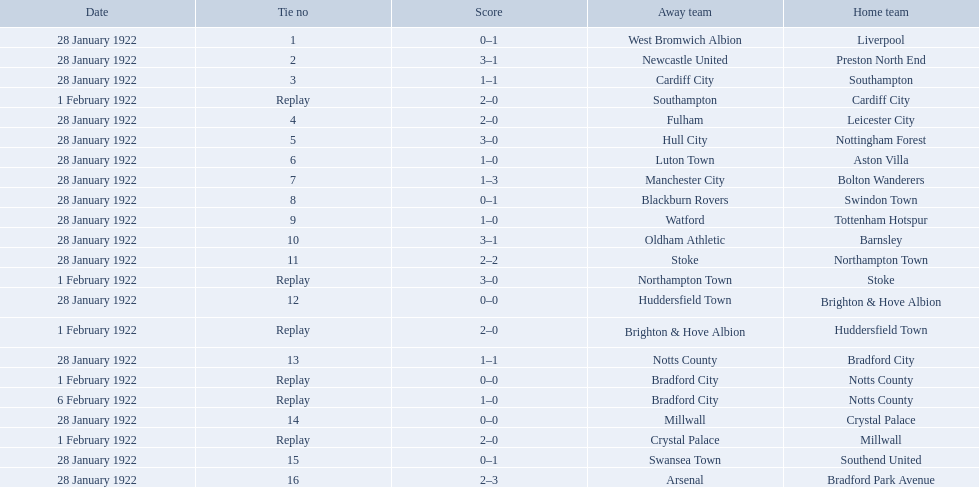What are all of the home teams? Liverpool, Preston North End, Southampton, Cardiff City, Leicester City, Nottingham Forest, Aston Villa, Bolton Wanderers, Swindon Town, Tottenham Hotspur, Barnsley, Northampton Town, Stoke, Brighton & Hove Albion, Huddersfield Town, Bradford City, Notts County, Notts County, Crystal Palace, Millwall, Southend United, Bradford Park Avenue. What were the scores? 0–1, 3–1, 1–1, 2–0, 2–0, 3–0, 1–0, 1–3, 0–1, 1–0, 3–1, 2–2, 3–0, 0–0, 2–0, 1–1, 0–0, 1–0, 0–0, 2–0, 0–1, 2–3. On which dates did they play? 28 January 1922, 28 January 1922, 28 January 1922, 1 February 1922, 28 January 1922, 28 January 1922, 28 January 1922, 28 January 1922, 28 January 1922, 28 January 1922, 28 January 1922, 28 January 1922, 1 February 1922, 28 January 1922, 1 February 1922, 28 January 1922, 1 February 1922, 6 February 1922, 28 January 1922, 1 February 1922, 28 January 1922, 28 January 1922. Which teams played on 28 january 1922? Liverpool, Preston North End, Southampton, Leicester City, Nottingham Forest, Aston Villa, Bolton Wanderers, Swindon Town, Tottenham Hotspur, Barnsley, Northampton Town, Brighton & Hove Albion, Bradford City, Crystal Palace, Southend United, Bradford Park Avenue. Of those, which scored the same as aston villa? Tottenham Hotspur. 